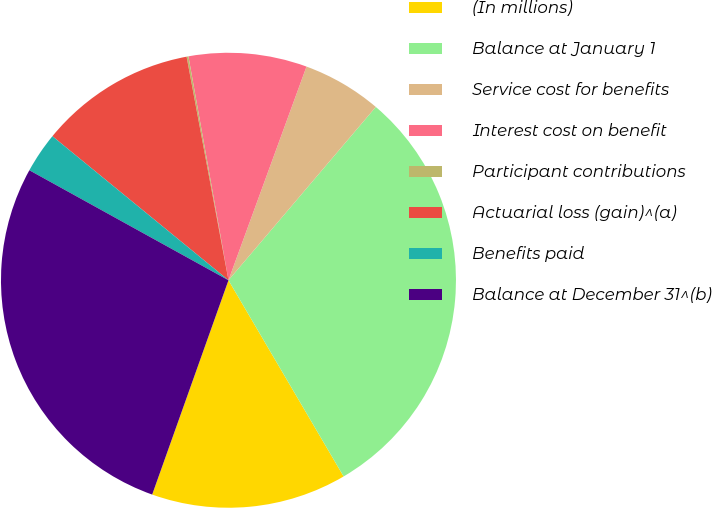<chart> <loc_0><loc_0><loc_500><loc_500><pie_chart><fcel>(In millions)<fcel>Balance at January 1<fcel>Service cost for benefits<fcel>Interest cost on benefit<fcel>Participant contributions<fcel>Actuarial loss (gain)^(a)<fcel>Benefits paid<fcel>Balance at December 31^(b)<nl><fcel>13.89%<fcel>30.34%<fcel>5.64%<fcel>8.39%<fcel>0.13%<fcel>11.14%<fcel>2.88%<fcel>27.59%<nl></chart> 